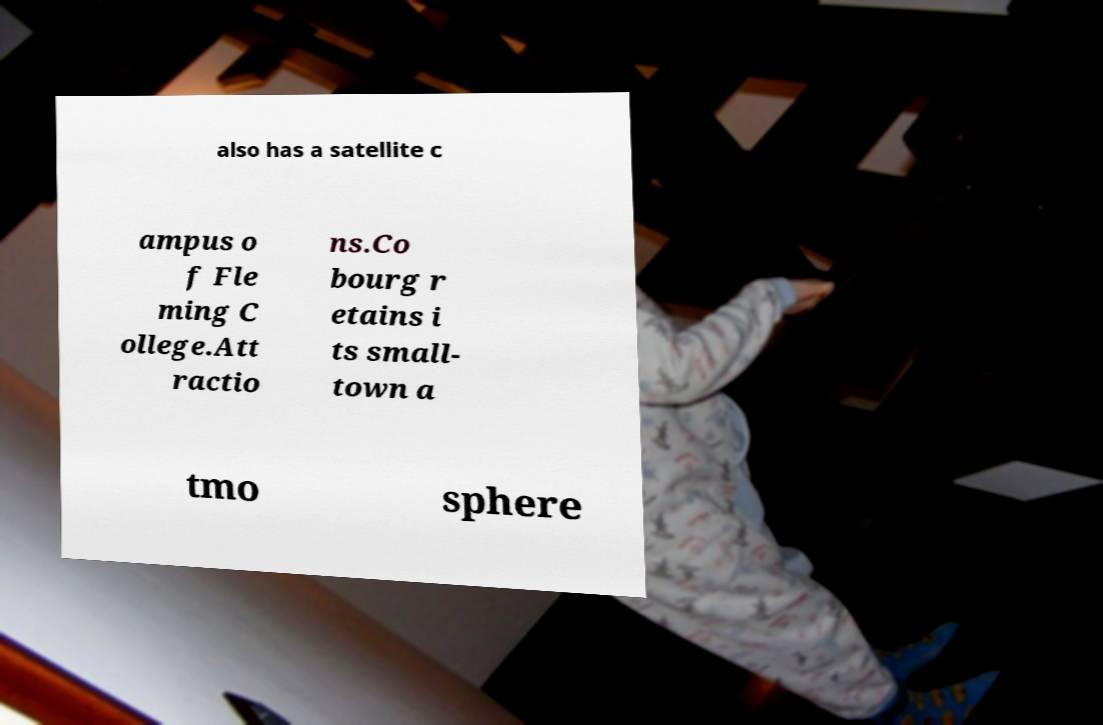I need the written content from this picture converted into text. Can you do that? also has a satellite c ampus o f Fle ming C ollege.Att ractio ns.Co bourg r etains i ts small- town a tmo sphere 